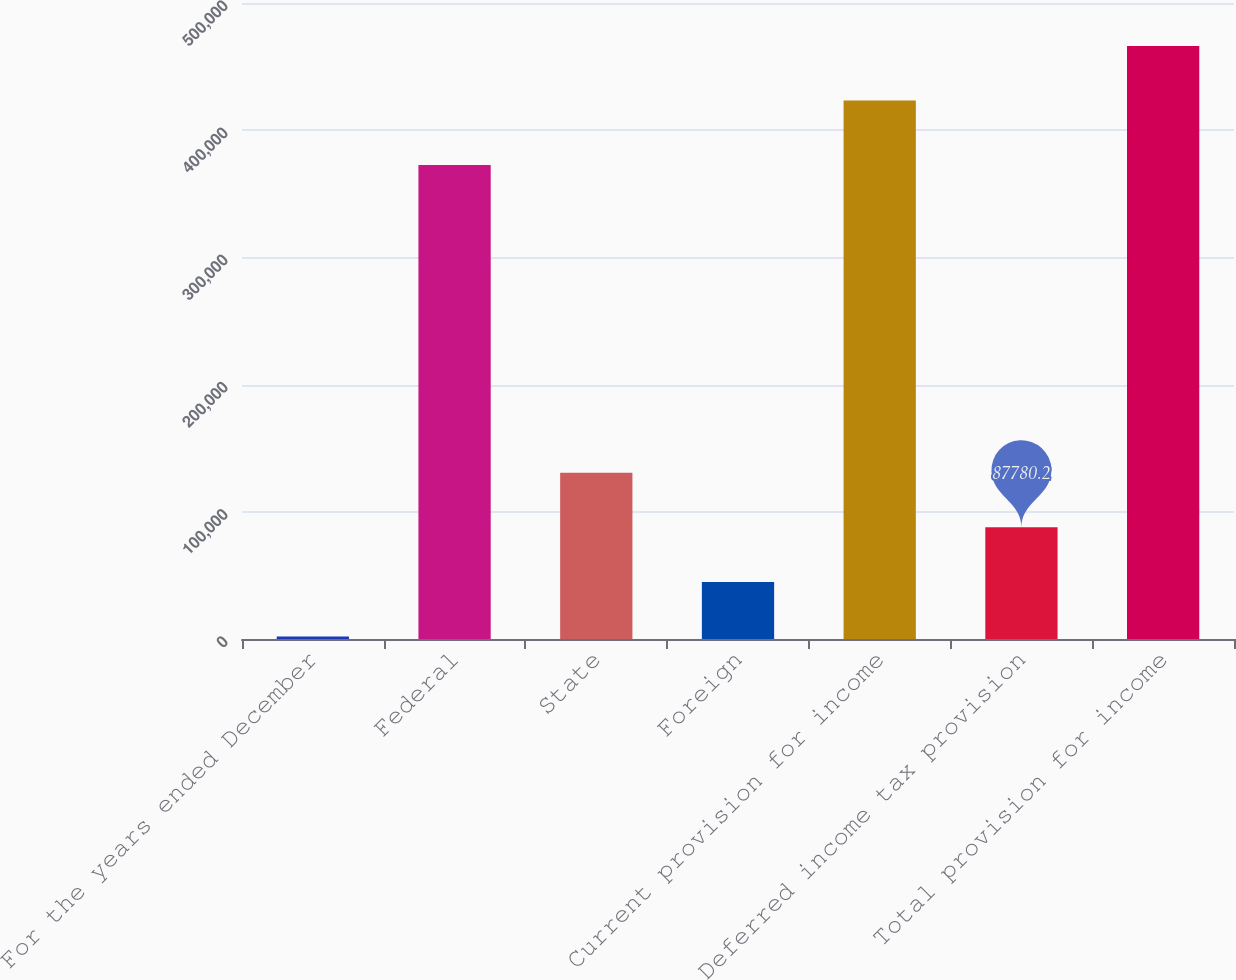Convert chart. <chart><loc_0><loc_0><loc_500><loc_500><bar_chart><fcel>For the years ended December<fcel>Federal<fcel>State<fcel>Foreign<fcel>Current provision for income<fcel>Deferred income tax provision<fcel>Total provision for income<nl><fcel>2013<fcel>372649<fcel>130664<fcel>44896.6<fcel>423392<fcel>87780.2<fcel>466276<nl></chart> 